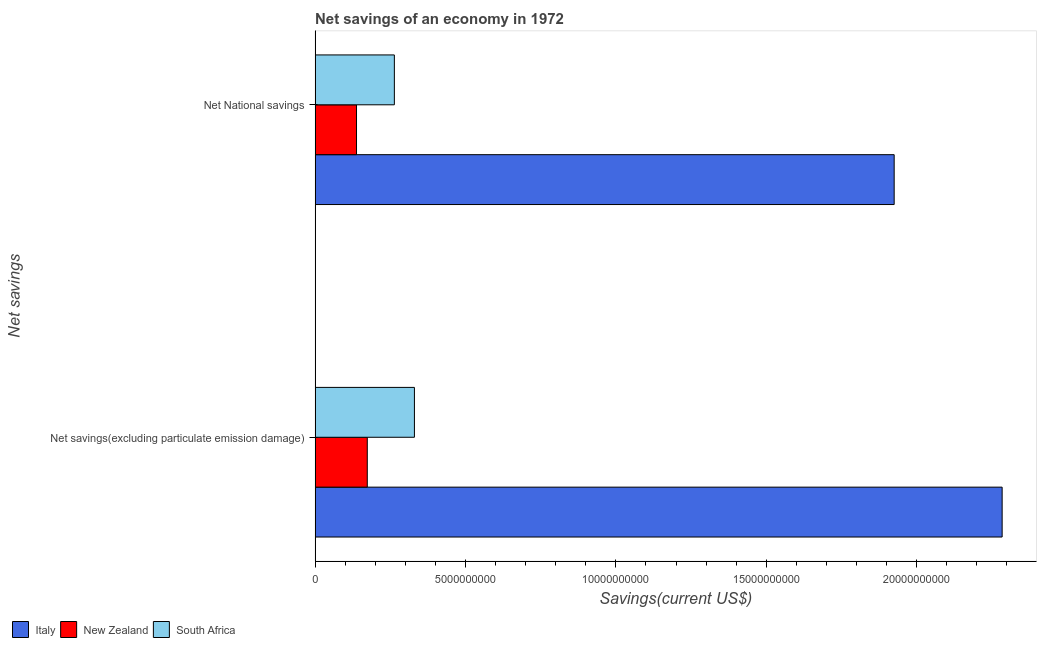How many groups of bars are there?
Make the answer very short. 2. Are the number of bars per tick equal to the number of legend labels?
Keep it short and to the point. Yes. How many bars are there on the 1st tick from the top?
Keep it short and to the point. 3. What is the label of the 2nd group of bars from the top?
Provide a short and direct response. Net savings(excluding particulate emission damage). What is the net savings(excluding particulate emission damage) in New Zealand?
Provide a short and direct response. 1.73e+09. Across all countries, what is the maximum net national savings?
Offer a terse response. 1.93e+1. Across all countries, what is the minimum net savings(excluding particulate emission damage)?
Offer a very short reply. 1.73e+09. In which country was the net savings(excluding particulate emission damage) maximum?
Make the answer very short. Italy. In which country was the net savings(excluding particulate emission damage) minimum?
Your answer should be very brief. New Zealand. What is the total net national savings in the graph?
Your answer should be very brief. 2.33e+1. What is the difference between the net savings(excluding particulate emission damage) in South Africa and that in Italy?
Offer a terse response. -1.95e+1. What is the difference between the net national savings in New Zealand and the net savings(excluding particulate emission damage) in South Africa?
Ensure brevity in your answer.  -1.93e+09. What is the average net savings(excluding particulate emission damage) per country?
Give a very brief answer. 9.29e+09. What is the difference between the net national savings and net savings(excluding particulate emission damage) in New Zealand?
Give a very brief answer. -3.58e+08. What is the ratio of the net savings(excluding particulate emission damage) in New Zealand to that in Italy?
Give a very brief answer. 0.08. What does the 2nd bar from the top in Net National savings represents?
Keep it short and to the point. New Zealand. What does the 2nd bar from the bottom in Net savings(excluding particulate emission damage) represents?
Your response must be concise. New Zealand. How many bars are there?
Keep it short and to the point. 6. Are all the bars in the graph horizontal?
Provide a succinct answer. Yes. How many legend labels are there?
Your answer should be very brief. 3. How are the legend labels stacked?
Ensure brevity in your answer.  Horizontal. What is the title of the graph?
Your response must be concise. Net savings of an economy in 1972. What is the label or title of the X-axis?
Ensure brevity in your answer.  Savings(current US$). What is the label or title of the Y-axis?
Your answer should be very brief. Net savings. What is the Savings(current US$) of Italy in Net savings(excluding particulate emission damage)?
Give a very brief answer. 2.28e+1. What is the Savings(current US$) of New Zealand in Net savings(excluding particulate emission damage)?
Your answer should be compact. 1.73e+09. What is the Savings(current US$) of South Africa in Net savings(excluding particulate emission damage)?
Offer a terse response. 3.30e+09. What is the Savings(current US$) of Italy in Net National savings?
Your answer should be very brief. 1.93e+1. What is the Savings(current US$) of New Zealand in Net National savings?
Ensure brevity in your answer.  1.38e+09. What is the Savings(current US$) in South Africa in Net National savings?
Keep it short and to the point. 2.64e+09. Across all Net savings, what is the maximum Savings(current US$) in Italy?
Keep it short and to the point. 2.28e+1. Across all Net savings, what is the maximum Savings(current US$) in New Zealand?
Offer a terse response. 1.73e+09. Across all Net savings, what is the maximum Savings(current US$) of South Africa?
Provide a succinct answer. 3.30e+09. Across all Net savings, what is the minimum Savings(current US$) in Italy?
Your answer should be compact. 1.93e+1. Across all Net savings, what is the minimum Savings(current US$) of New Zealand?
Provide a short and direct response. 1.38e+09. Across all Net savings, what is the minimum Savings(current US$) in South Africa?
Your response must be concise. 2.64e+09. What is the total Savings(current US$) in Italy in the graph?
Provide a short and direct response. 4.21e+1. What is the total Savings(current US$) in New Zealand in the graph?
Give a very brief answer. 3.11e+09. What is the total Savings(current US$) of South Africa in the graph?
Your answer should be very brief. 5.94e+09. What is the difference between the Savings(current US$) of Italy in Net savings(excluding particulate emission damage) and that in Net National savings?
Offer a very short reply. 3.59e+09. What is the difference between the Savings(current US$) of New Zealand in Net savings(excluding particulate emission damage) and that in Net National savings?
Give a very brief answer. 3.58e+08. What is the difference between the Savings(current US$) of South Africa in Net savings(excluding particulate emission damage) and that in Net National savings?
Offer a terse response. 6.67e+08. What is the difference between the Savings(current US$) in Italy in Net savings(excluding particulate emission damage) and the Savings(current US$) in New Zealand in Net National savings?
Provide a short and direct response. 2.15e+1. What is the difference between the Savings(current US$) in Italy in Net savings(excluding particulate emission damage) and the Savings(current US$) in South Africa in Net National savings?
Offer a very short reply. 2.02e+1. What is the difference between the Savings(current US$) of New Zealand in Net savings(excluding particulate emission damage) and the Savings(current US$) of South Africa in Net National savings?
Your answer should be very brief. -9.01e+08. What is the average Savings(current US$) of Italy per Net savings?
Ensure brevity in your answer.  2.10e+1. What is the average Savings(current US$) of New Zealand per Net savings?
Your answer should be very brief. 1.56e+09. What is the average Savings(current US$) in South Africa per Net savings?
Provide a succinct answer. 2.97e+09. What is the difference between the Savings(current US$) of Italy and Savings(current US$) of New Zealand in Net savings(excluding particulate emission damage)?
Give a very brief answer. 2.11e+1. What is the difference between the Savings(current US$) in Italy and Savings(current US$) in South Africa in Net savings(excluding particulate emission damage)?
Provide a succinct answer. 1.95e+1. What is the difference between the Savings(current US$) of New Zealand and Savings(current US$) of South Africa in Net savings(excluding particulate emission damage)?
Offer a terse response. -1.57e+09. What is the difference between the Savings(current US$) of Italy and Savings(current US$) of New Zealand in Net National savings?
Offer a very short reply. 1.79e+1. What is the difference between the Savings(current US$) in Italy and Savings(current US$) in South Africa in Net National savings?
Your response must be concise. 1.66e+1. What is the difference between the Savings(current US$) of New Zealand and Savings(current US$) of South Africa in Net National savings?
Keep it short and to the point. -1.26e+09. What is the ratio of the Savings(current US$) in Italy in Net savings(excluding particulate emission damage) to that in Net National savings?
Your answer should be compact. 1.19. What is the ratio of the Savings(current US$) of New Zealand in Net savings(excluding particulate emission damage) to that in Net National savings?
Offer a very short reply. 1.26. What is the ratio of the Savings(current US$) in South Africa in Net savings(excluding particulate emission damage) to that in Net National savings?
Ensure brevity in your answer.  1.25. What is the difference between the highest and the second highest Savings(current US$) in Italy?
Provide a succinct answer. 3.59e+09. What is the difference between the highest and the second highest Savings(current US$) of New Zealand?
Offer a very short reply. 3.58e+08. What is the difference between the highest and the second highest Savings(current US$) in South Africa?
Your answer should be very brief. 6.67e+08. What is the difference between the highest and the lowest Savings(current US$) of Italy?
Provide a short and direct response. 3.59e+09. What is the difference between the highest and the lowest Savings(current US$) in New Zealand?
Your answer should be compact. 3.58e+08. What is the difference between the highest and the lowest Savings(current US$) of South Africa?
Keep it short and to the point. 6.67e+08. 